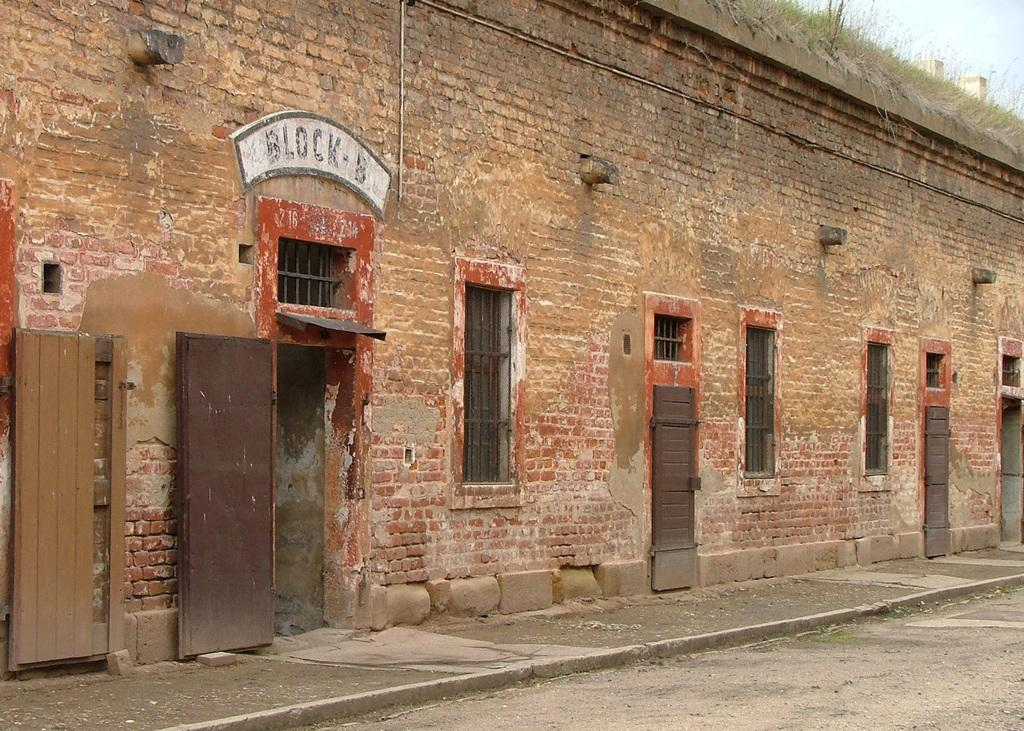What type of structure is present in the image? There is a building in the image. What is the color of the building? The building is brown in color. What feature can be seen on the building? The building has windows. What type of vegetation is visible behind the building? There is grass visible behind the building. What part of the natural environment is visible in the image? The sky is visible in the image. What type of paper is being used to create the country in the image? There is no country or paper present in the image; it features a brown building with windows and a grassy background. 